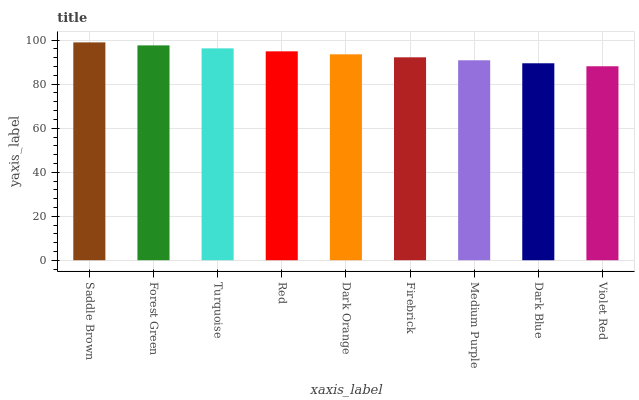Is Violet Red the minimum?
Answer yes or no. Yes. Is Saddle Brown the maximum?
Answer yes or no. Yes. Is Forest Green the minimum?
Answer yes or no. No. Is Forest Green the maximum?
Answer yes or no. No. Is Saddle Brown greater than Forest Green?
Answer yes or no. Yes. Is Forest Green less than Saddle Brown?
Answer yes or no. Yes. Is Forest Green greater than Saddle Brown?
Answer yes or no. No. Is Saddle Brown less than Forest Green?
Answer yes or no. No. Is Dark Orange the high median?
Answer yes or no. Yes. Is Dark Orange the low median?
Answer yes or no. Yes. Is Red the high median?
Answer yes or no. No. Is Violet Red the low median?
Answer yes or no. No. 